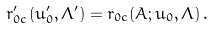Convert formula to latex. <formula><loc_0><loc_0><loc_500><loc_500>r _ { 0 c } ^ { \prime } ( u _ { 0 } ^ { \prime } , \Lambda ^ { \prime } ) = r _ { 0 c } ( { A } ; u _ { 0 } , \Lambda ) \, .</formula> 